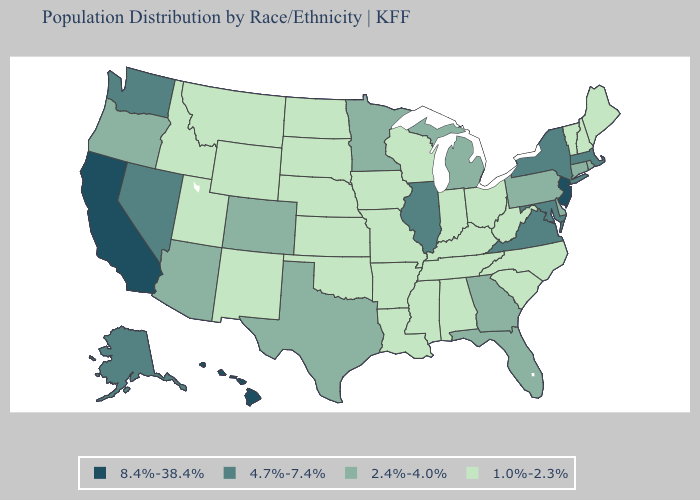Name the states that have a value in the range 8.4%-38.4%?
Concise answer only. California, Hawaii, New Jersey. Among the states that border Florida , which have the lowest value?
Give a very brief answer. Alabama. What is the value of West Virginia?
Short answer required. 1.0%-2.3%. Among the states that border Arizona , which have the highest value?
Quick response, please. California. Is the legend a continuous bar?
Write a very short answer. No. Does Idaho have the highest value in the USA?
Give a very brief answer. No. What is the value of New York?
Concise answer only. 4.7%-7.4%. Name the states that have a value in the range 2.4%-4.0%?
Answer briefly. Arizona, Colorado, Connecticut, Delaware, Florida, Georgia, Michigan, Minnesota, Oregon, Pennsylvania, Rhode Island, Texas. Name the states that have a value in the range 8.4%-38.4%?
Write a very short answer. California, Hawaii, New Jersey. Does Ohio have a lower value than Colorado?
Give a very brief answer. Yes. Does the map have missing data?
Give a very brief answer. No. Does California have the highest value in the West?
Give a very brief answer. Yes. Among the states that border Idaho , which have the lowest value?
Short answer required. Montana, Utah, Wyoming. What is the value of New Mexico?
Be succinct. 1.0%-2.3%. What is the value of Kentucky?
Quick response, please. 1.0%-2.3%. 